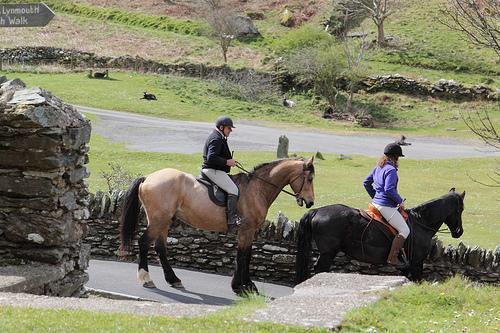How many horses in picture?
Give a very brief answer. 2. 